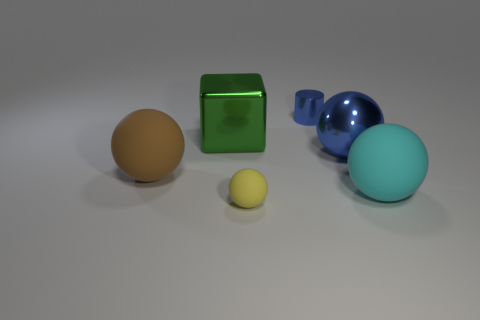How many other shiny objects are the same size as the brown thing?
Provide a short and direct response. 2. What is the shape of the green object?
Your answer should be compact. Cube. What is the size of the matte object that is both on the left side of the blue cylinder and right of the large green cube?
Make the answer very short. Small. There is a sphere to the left of the small matte object; what is its material?
Ensure brevity in your answer.  Rubber. Does the cylinder have the same color as the large metallic thing to the right of the yellow matte ball?
Your response must be concise. Yes. How many things are big rubber things that are on the right side of the metallic cylinder or matte balls that are behind the big cyan rubber object?
Ensure brevity in your answer.  2. What color is the matte thing that is to the left of the cyan object and in front of the big brown matte sphere?
Make the answer very short. Yellow. Is the number of gray rubber cylinders greater than the number of small yellow objects?
Make the answer very short. No. There is a big shiny object that is to the right of the small blue object; is its shape the same as the yellow matte object?
Keep it short and to the point. Yes. What number of rubber objects are small yellow spheres or cyan objects?
Ensure brevity in your answer.  2. 